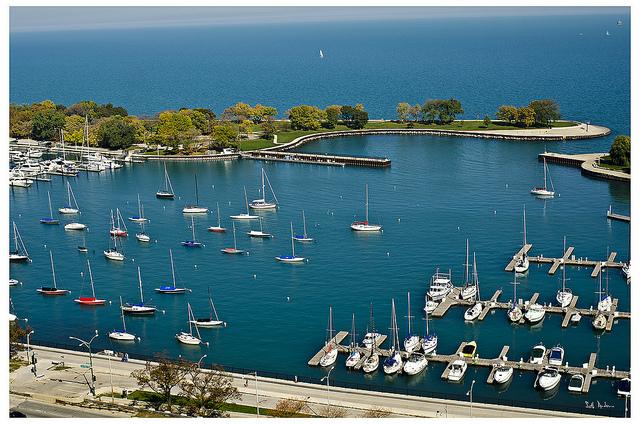How many boats are shown?
Keep it brief. 35. Are there any people in this picture?
Write a very short answer. No. Does this appear to be a European port?
Be succinct. Yes. Are there boats in the harbor?
Write a very short answer. Yes. 